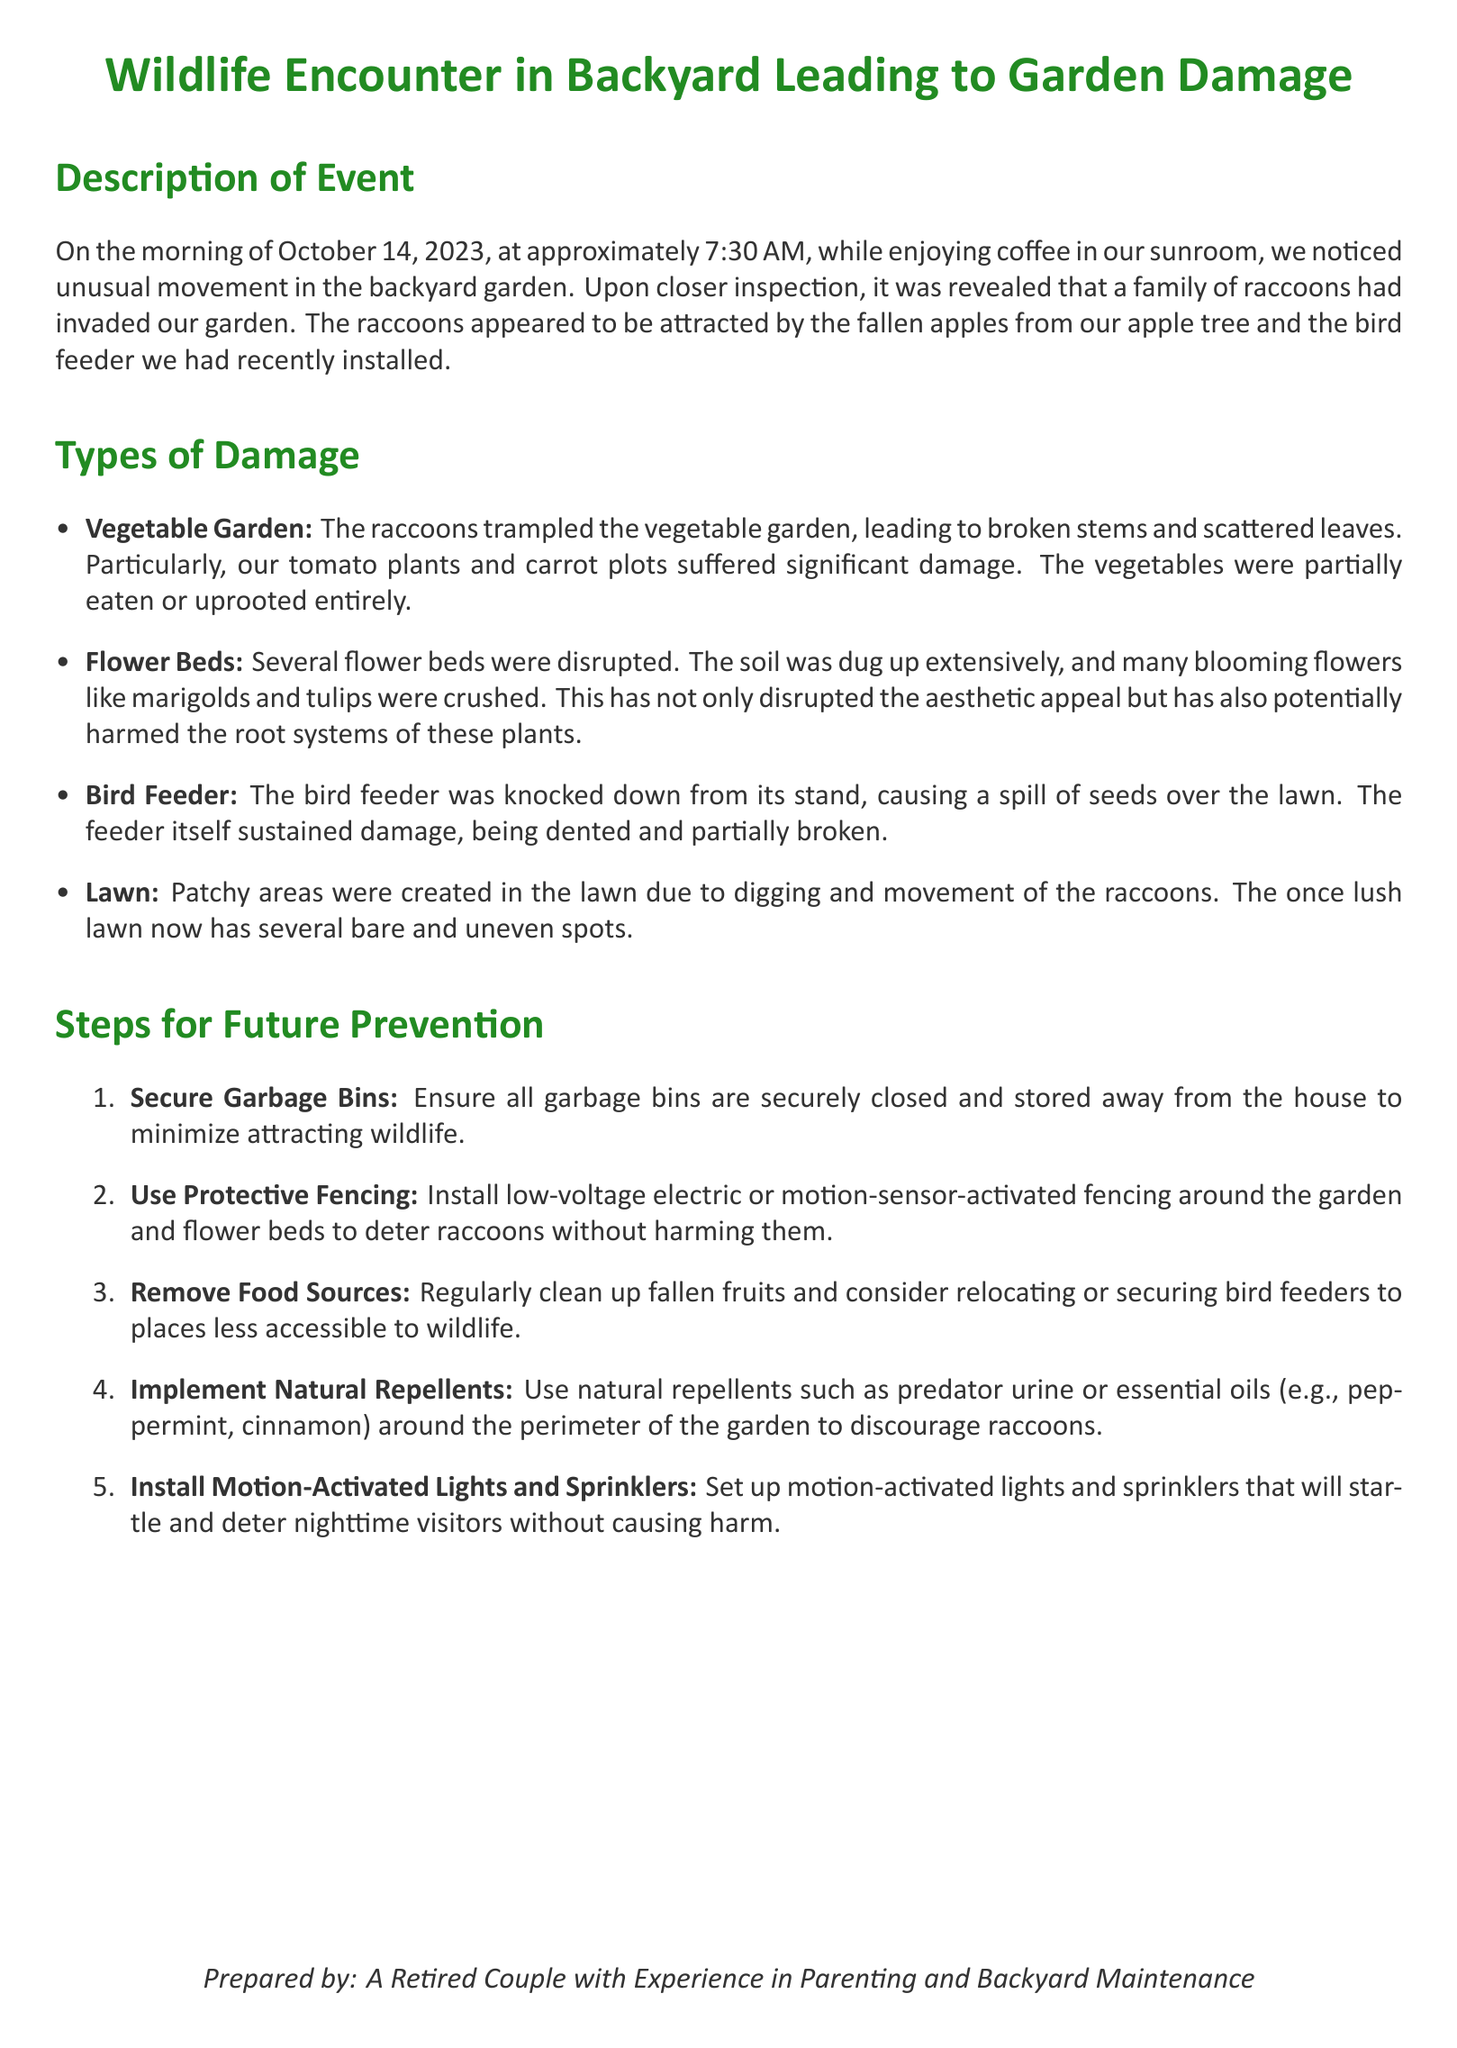What date did the wildlife encounter occur? The event description specifies that the encounter occurred on October 14, 2023.
Answer: October 14, 2023 What time was the event first noticed? The description states that the unusual movement was noticed at approximately 7:30 AM.
Answer: 7:30 AM Which plants suffered significant damage in the vegetable garden? The document lists tomato plants and carrot plots as significantly damaged.
Answer: Tomato plants and carrot plots What was damaged alongside the bird feeder? The report mentions that the bird feeder was knocked down, causing seed spillage and damage to the feeder itself.
Answer: Seeds spilled and feeder damaged What type of fencing is recommended for future prevention? The document suggests installing low-voltage electric or motion-sensor-activated fencing.
Answer: Electric or motion-sensor-activated fencing What are natural repellents mentioned in the report? The document suggests using predator urine or essential oils like peppermint and cinnamon as natural repellents.
Answer: Predator urine or essential oils How many steps for future prevention are listed? The report enumerates a total of five steps for future prevention.
Answer: Five steps What were the main wildlife involved in the encounter? The description indicates that a family of raccoons was responsible for the garden damage.
Answer: Raccoons What happened to the lawn due to the encounter? The document describes that the lawn developed patchy areas from the raccoons' digging and movement.
Answer: Patchy areas 